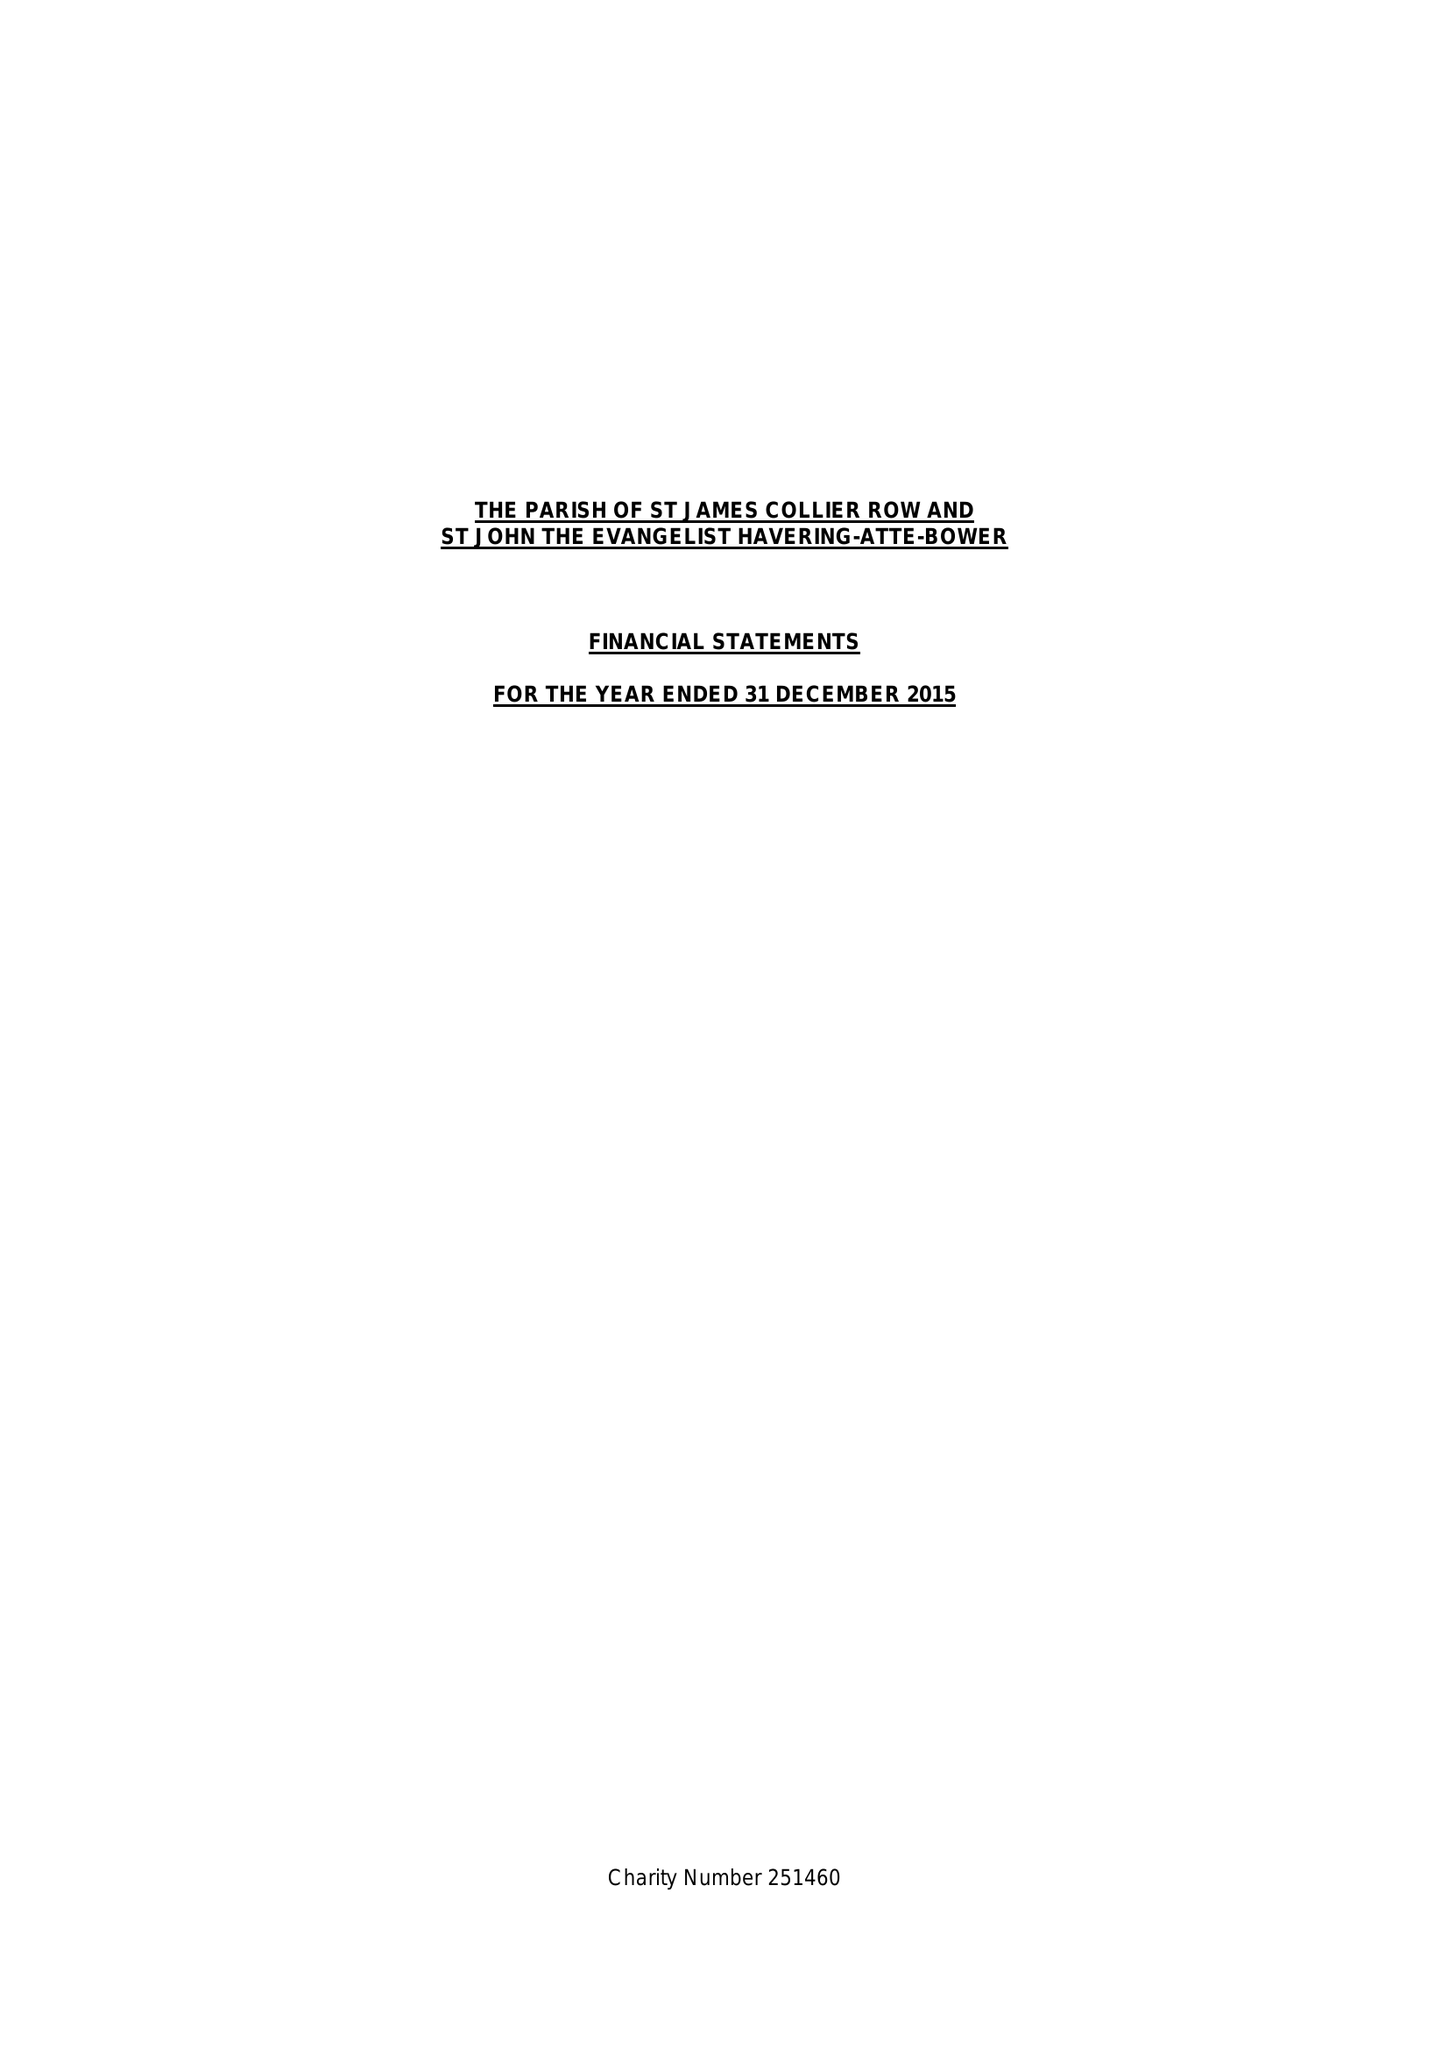What is the value for the address__postcode?
Answer the question using a single word or phrase. RM2 6NB 